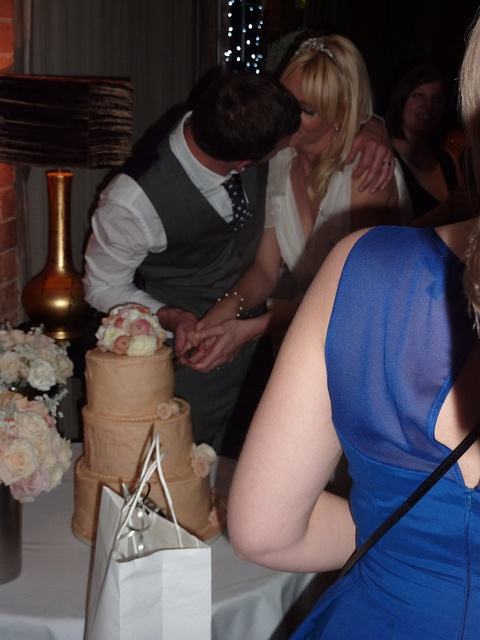Describe the objects in this image and their specific colors. I can see people in maroon, navy, blue, lightpink, and black tones, people in maroon, black, and gray tones, people in maroon, black, and gray tones, cake in maroon, gray, and brown tones, and handbag in maroon, darkgray, lightgray, and gray tones in this image. 